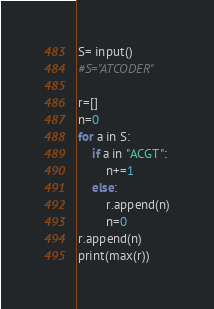Convert code to text. <code><loc_0><loc_0><loc_500><loc_500><_Python_>S= input()
#S="ATCODER"

r=[]
n=0
for a in S:
    if a in "ACGT":
        n+=1
    else:
        r.append(n)
        n=0
r.append(n)
print(max(r))
</code> 